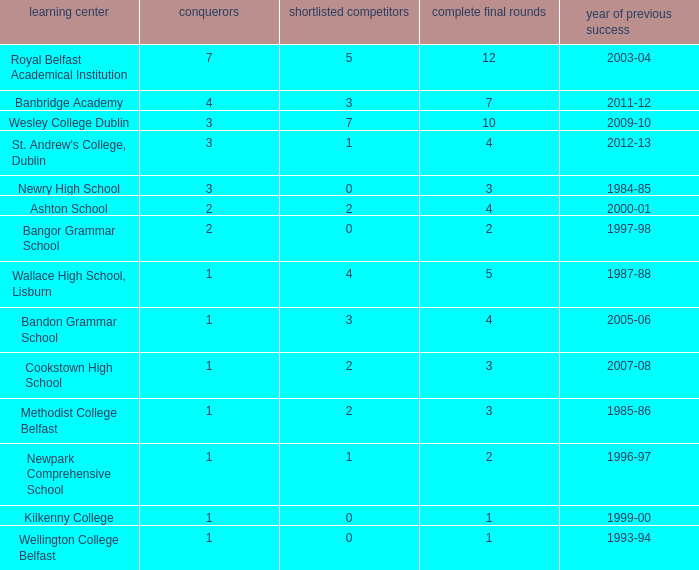In what year was the total finals at 10? 2009-10. 